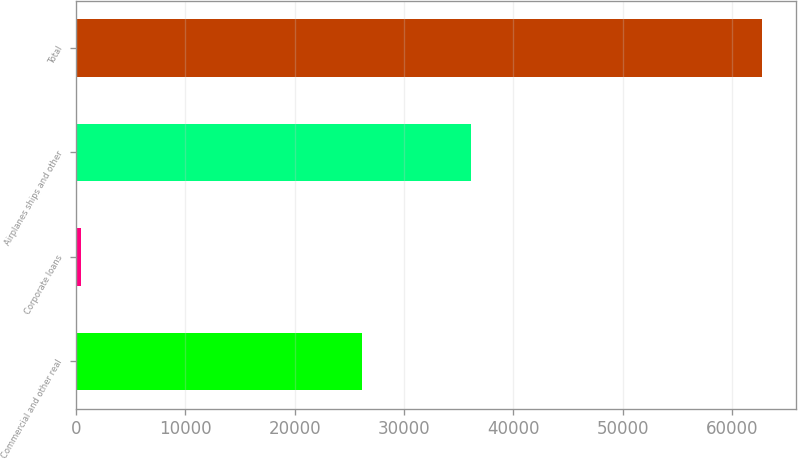Convert chart to OTSL. <chart><loc_0><loc_0><loc_500><loc_500><bar_chart><fcel>Commercial and other real<fcel>Corporate loans<fcel>Airplanes ships and other<fcel>Total<nl><fcel>26146<fcel>460<fcel>36143<fcel>62749<nl></chart> 